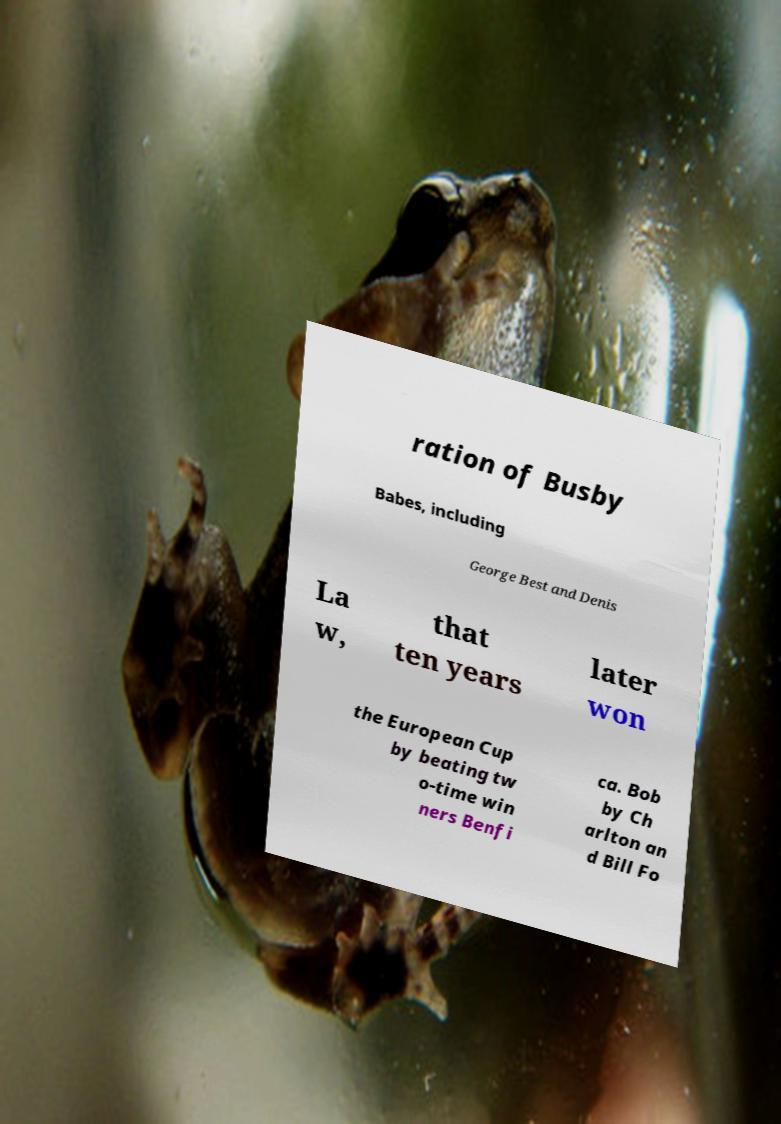Please identify and transcribe the text found in this image. ration of Busby Babes, including George Best and Denis La w, that ten years later won the European Cup by beating tw o-time win ners Benfi ca. Bob by Ch arlton an d Bill Fo 